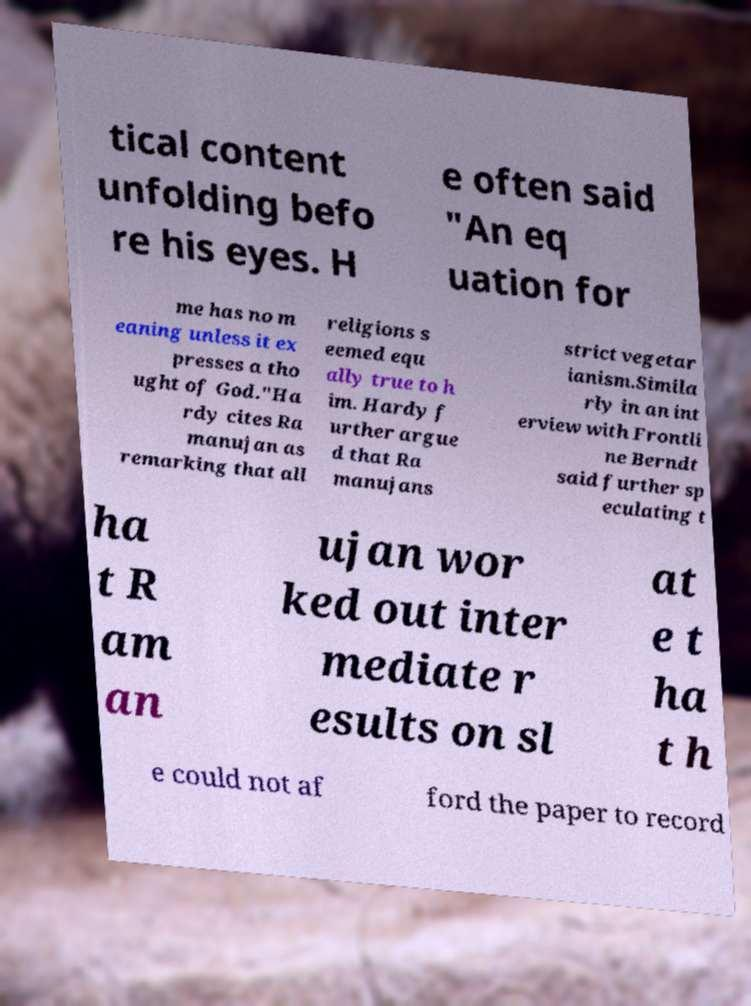Please read and relay the text visible in this image. What does it say? tical content unfolding befo re his eyes. H e often said "An eq uation for me has no m eaning unless it ex presses a tho ught of God."Ha rdy cites Ra manujan as remarking that all religions s eemed equ ally true to h im. Hardy f urther argue d that Ra manujans strict vegetar ianism.Simila rly in an int erview with Frontli ne Berndt said further sp eculating t ha t R am an ujan wor ked out inter mediate r esults on sl at e t ha t h e could not af ford the paper to record 